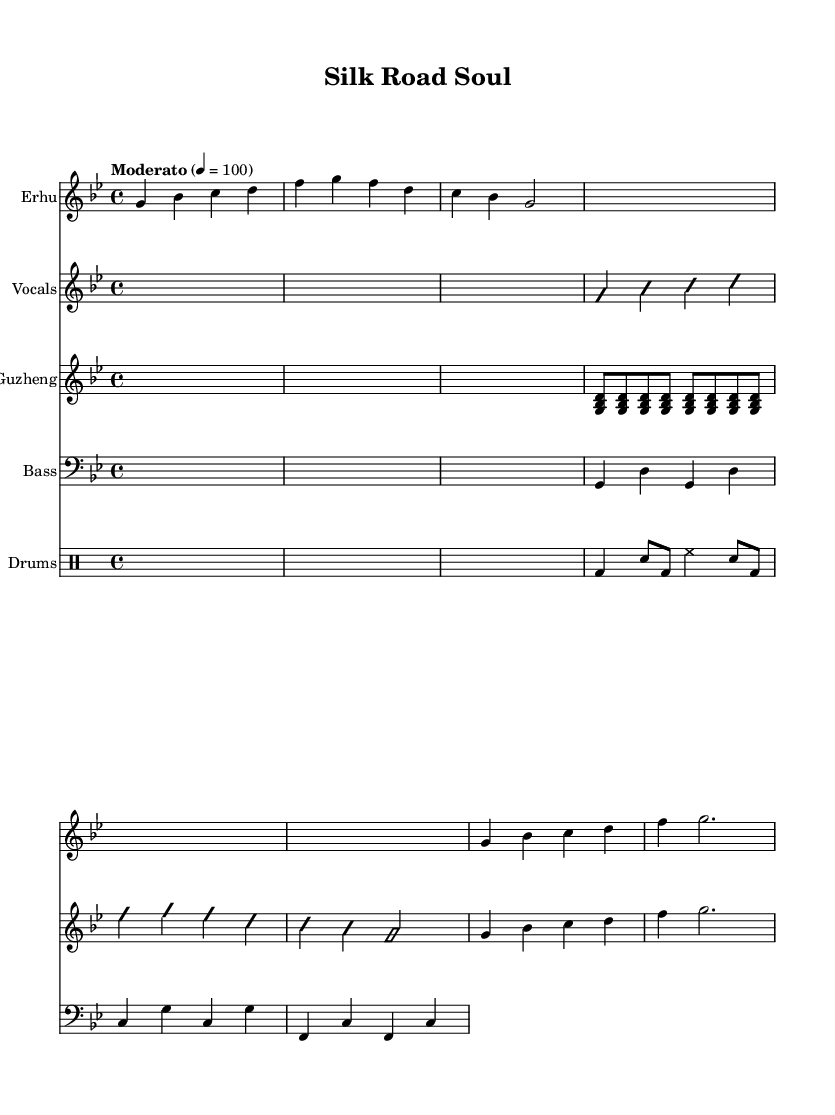What is the key signature of this music? The key signature of the music is G minor, which is indicated by the presence of two flats (B♭ and E♭).
Answer: G minor What is the time signature of the piece? The time signature shown on the sheet music is 4/4, meaning there are four beats in each measure.
Answer: 4/4 What is the tempo marking for this piece? The tempo marking indicates "Moderato" with a tempo of quarter note equals 100, suggesting a moderate pace for the music.
Answer: Moderato How many measures are in the erhu intro before the vocals begin? The erhu intro consists of two measures before it transitions to the chorus and then to the vocals. The intro section has an initial measure followed by a repeated measure.
Answer: 2 What instrumentation is primarily used in this composition? The main instruments used are the Erhu, Guzheng, Vocals, Bass, and Drums, which together create a fusion of traditional and modern elements.
Answer: Erhu, Guzheng, Vocals, Bass, Drums Describe the purpose of the improvisation marking in the vocals section. The 'improvisationOn' and 'improvisationOff' markings indicate sections where the vocalist is encouraged to improvise freely over the established melody, adding a personal touch to the performance.
Answer: Improvisation How is the bass line structured throughout the piece? The bass line consists of repetitive quarter notes and dotted half notes, providing a rhythmic foundation that complements the melody across the different sections.
Answer: Repetitive 